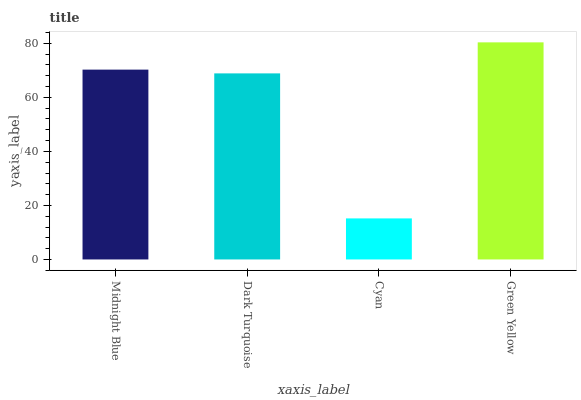Is Cyan the minimum?
Answer yes or no. Yes. Is Green Yellow the maximum?
Answer yes or no. Yes. Is Dark Turquoise the minimum?
Answer yes or no. No. Is Dark Turquoise the maximum?
Answer yes or no. No. Is Midnight Blue greater than Dark Turquoise?
Answer yes or no. Yes. Is Dark Turquoise less than Midnight Blue?
Answer yes or no. Yes. Is Dark Turquoise greater than Midnight Blue?
Answer yes or no. No. Is Midnight Blue less than Dark Turquoise?
Answer yes or no. No. Is Midnight Blue the high median?
Answer yes or no. Yes. Is Dark Turquoise the low median?
Answer yes or no. Yes. Is Green Yellow the high median?
Answer yes or no. No. Is Cyan the low median?
Answer yes or no. No. 